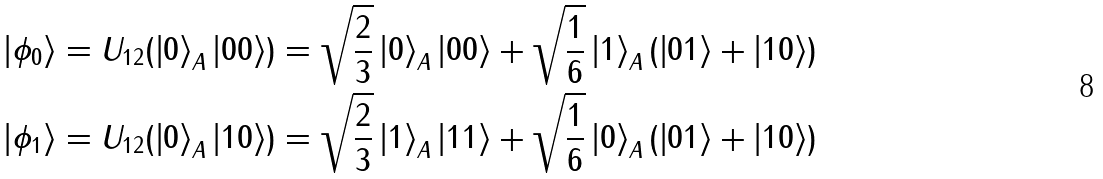<formula> <loc_0><loc_0><loc_500><loc_500>\left | \phi _ { 0 } \right \rangle & = U _ { 1 2 } ( \left | 0 \right \rangle _ { A } \left | 0 0 \right \rangle ) = \sqrt { \frac { 2 } { 3 } } \left | 0 \right \rangle _ { A } \left | 0 0 \right \rangle + \sqrt { \frac { 1 } { 6 } } \left | 1 \right \rangle _ { A } ( \left | 0 1 \right \rangle + \left | 1 0 \right \rangle ) \\ \left | \phi _ { 1 } \right \rangle & = U _ { 1 2 } ( \left | 0 \right \rangle _ { A } \left | 1 0 \right \rangle ) = \sqrt { \frac { 2 } { 3 } } \left | 1 \right \rangle _ { A } \left | 1 1 \right \rangle + \sqrt { \frac { 1 } { 6 } } \left | 0 \right \rangle _ { A } ( \left | 0 1 \right \rangle + \left | 1 0 \right \rangle )</formula> 